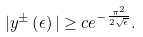<formula> <loc_0><loc_0><loc_500><loc_500>| y ^ { \pm } \left ( \epsilon \right ) | \geq c e ^ { - \frac { \pi ^ { 2 } } { 2 \sqrt { \epsilon } } } .</formula> 